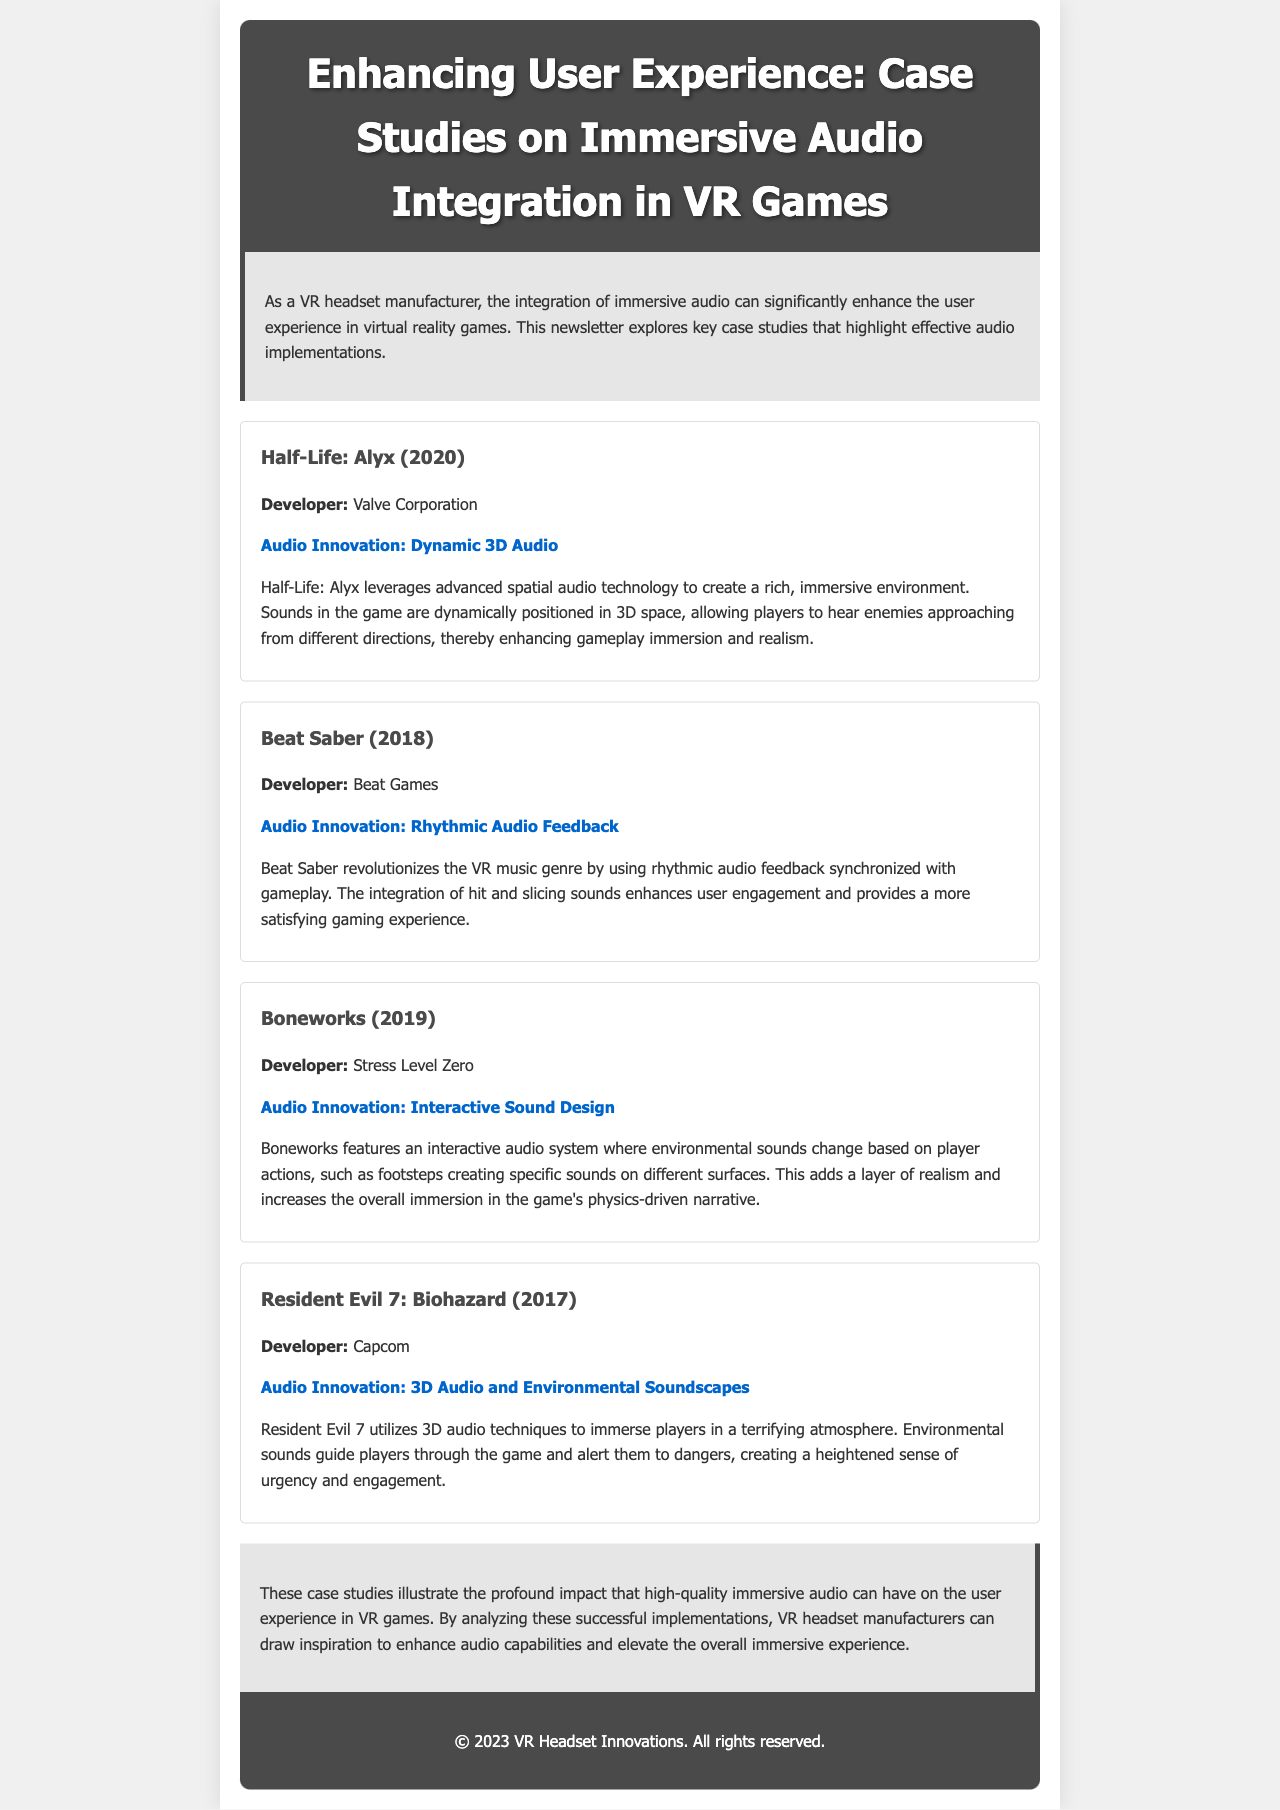What is the title of the newsletter? The title is prominently displayed in the header section of the newsletter.
Answer: Enhancing User Experience: Case Studies on Immersive Audio Integration in VR Games Who developed Half-Life: Alyx? The developer of Half-Life: Alyx is mentioned in the case study section.
Answer: Valve Corporation What audio innovation is featured in Beat Saber? The audio innovation is stated in the case study summary for Beat Saber.
Answer: Rhythmic Audio Feedback Which game uses interactive sound design? This information is found in the case study description for Boneworks.
Answer: Boneworks How many case studies are mentioned in the newsletter? The number of case studies is reflected in the section discussing the various games.
Answer: Four What is a key benefit of immersive audio as described in the conclusion? The conclusion outlines the overall impact of immersive audio on user experience.
Answer: User experience What year was Resident Evil 7: Biohazard released? The release year is provided in the case study for Resident Evil 7.
Answer: 2017 What color is used for the header background? This information is derived from the styling of the header section.
Answer: Dark gray Which game's audio innovation includes 3D audio and environmental soundscapes? This is specified in the case study for Resident Evil 7: Biohazard.
Answer: Resident Evil 7: Biohazard 